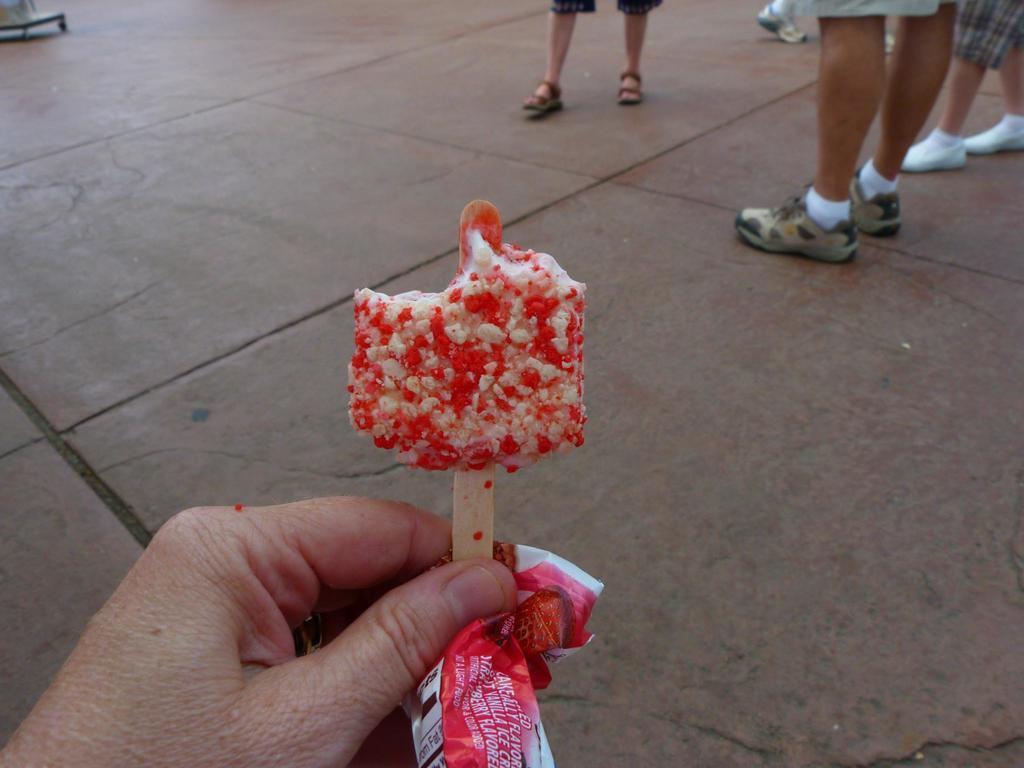Could you give a brief overview of what you see in this image? In this picture I can observe an ice cream which is in red and white color in the middle of the picture. In the background I can observe some people standing on the floor. 